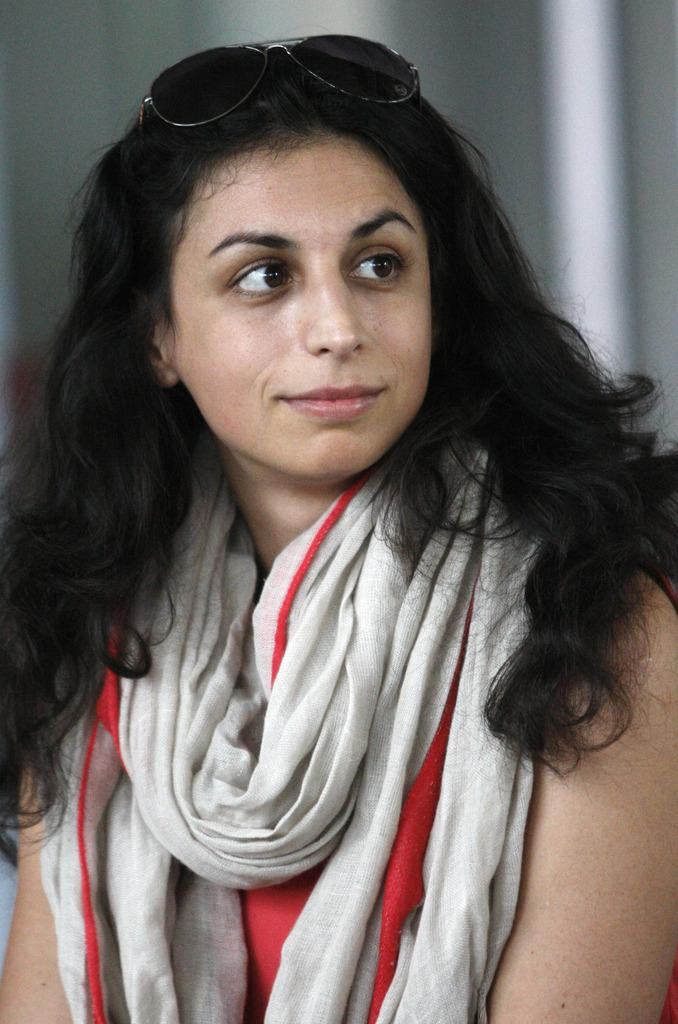Who is present in the image? There is a woman in the image. What is the woman doing in the image? The woman is smiling in the image. What type of quartz can be seen in the woman's hand in the image? There is no quartz present in the image; the woman is simply smiling. What kind of wave is visible in the background of the image? There is no wave visible in the image; it only features a woman smiling. 